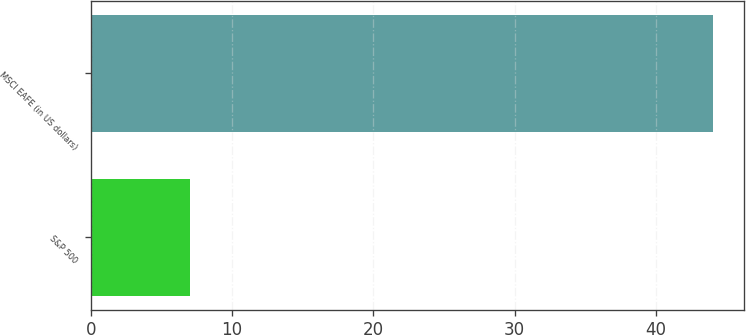Convert chart to OTSL. <chart><loc_0><loc_0><loc_500><loc_500><bar_chart><fcel>S&P 500<fcel>MSCI EAFE (in US dollars)<nl><fcel>7<fcel>44<nl></chart> 